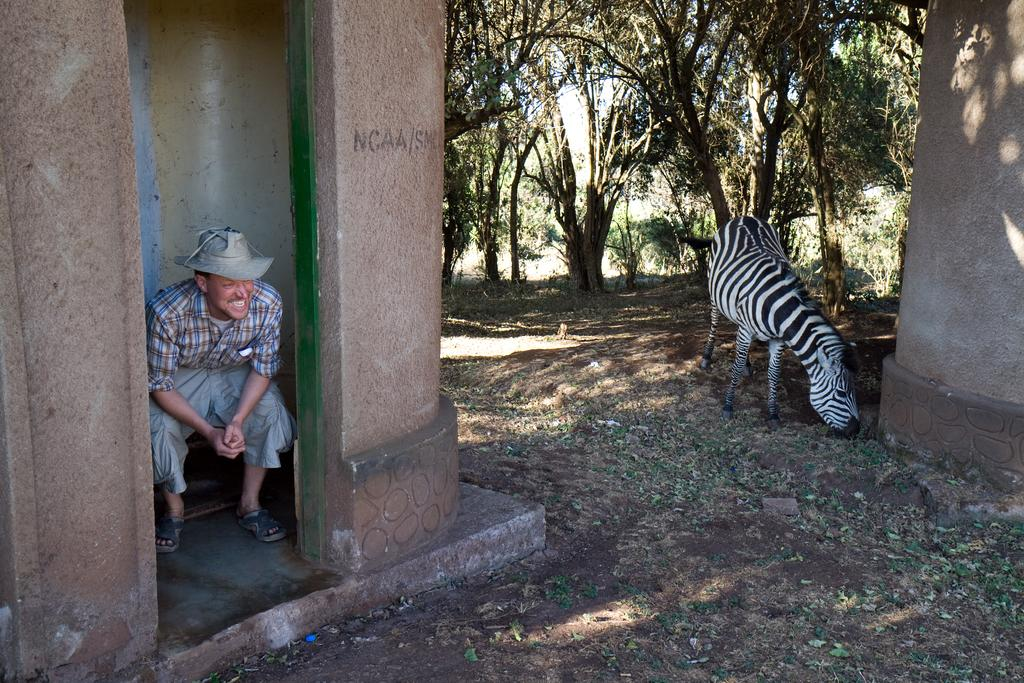Who is present in the image? There is a man in the image. What is the man doing in the image? The man is seated. What is the man wearing on his head? The man is wearing a cap. What type of animal can be seen in the image? There is a zebra in the image. What can be seen in the background of the image? There are trees in the background of the image. What type of copper material is the man using to spy on the zebra in the image? There is no copper material or spying activity present in the image. 